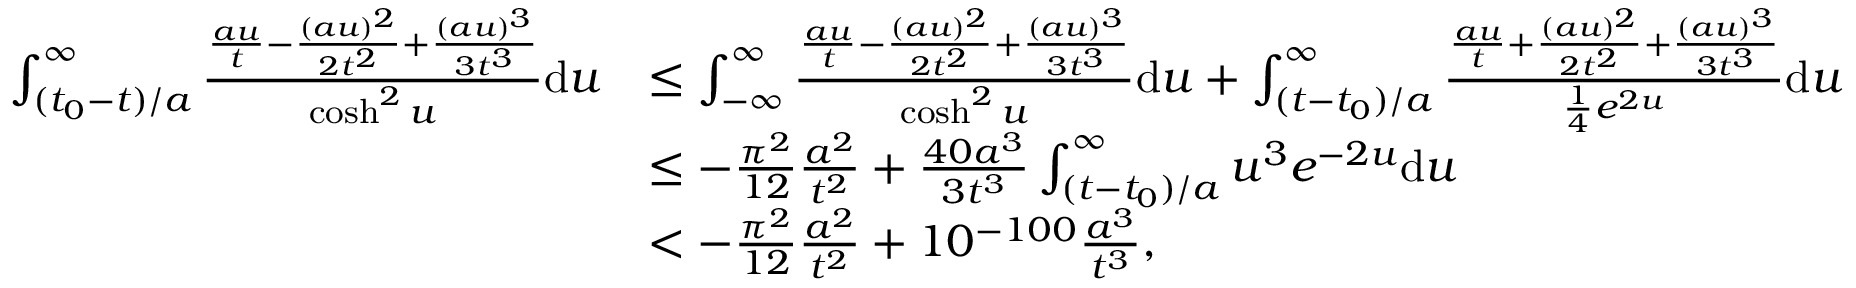<formula> <loc_0><loc_0><loc_500><loc_500>\begin{array} { r l } { \int _ { ( t _ { 0 } - t ) / a } ^ { \infty } \frac { \frac { a u } { t } - \frac { ( a u ) ^ { 2 } } { 2 t ^ { 2 } } + \frac { ( a u ) ^ { 3 } } { 3 t ^ { 3 } } } { \cosh ^ { 2 } u } d u } & { \leq \int _ { - \infty } ^ { \infty } \frac { \frac { a u } { t } - \frac { ( a u ) ^ { 2 } } { 2 t ^ { 2 } } + \frac { ( a u ) ^ { 3 } } { 3 t ^ { 3 } } } { \cosh ^ { 2 } u } d u + \int _ { ( t - t _ { 0 } ) / a } ^ { \infty } \frac { \frac { a u } { t } + \frac { ( a u ) ^ { 2 } } { 2 t ^ { 2 } } + \frac { ( a u ) ^ { 3 } } { 3 t ^ { 3 } } } { \frac { 1 } { 4 } e ^ { 2 u } } d u } \\ & { \leq - \frac { \pi ^ { 2 } } { 1 2 } \frac { a ^ { 2 } } { t ^ { 2 } } + \frac { 4 0 a ^ { 3 } } { 3 t ^ { 3 } } \int _ { ( t - t _ { 0 } ) / a } ^ { \infty } u ^ { 3 } e ^ { - 2 u } d u } \\ & { < - \frac { \pi ^ { 2 } } { 1 2 } \frac { a ^ { 2 } } { t ^ { 2 } } + 1 0 ^ { - 1 0 0 } \frac { a ^ { 3 } } { t ^ { 3 } } , } \end{array}</formula> 